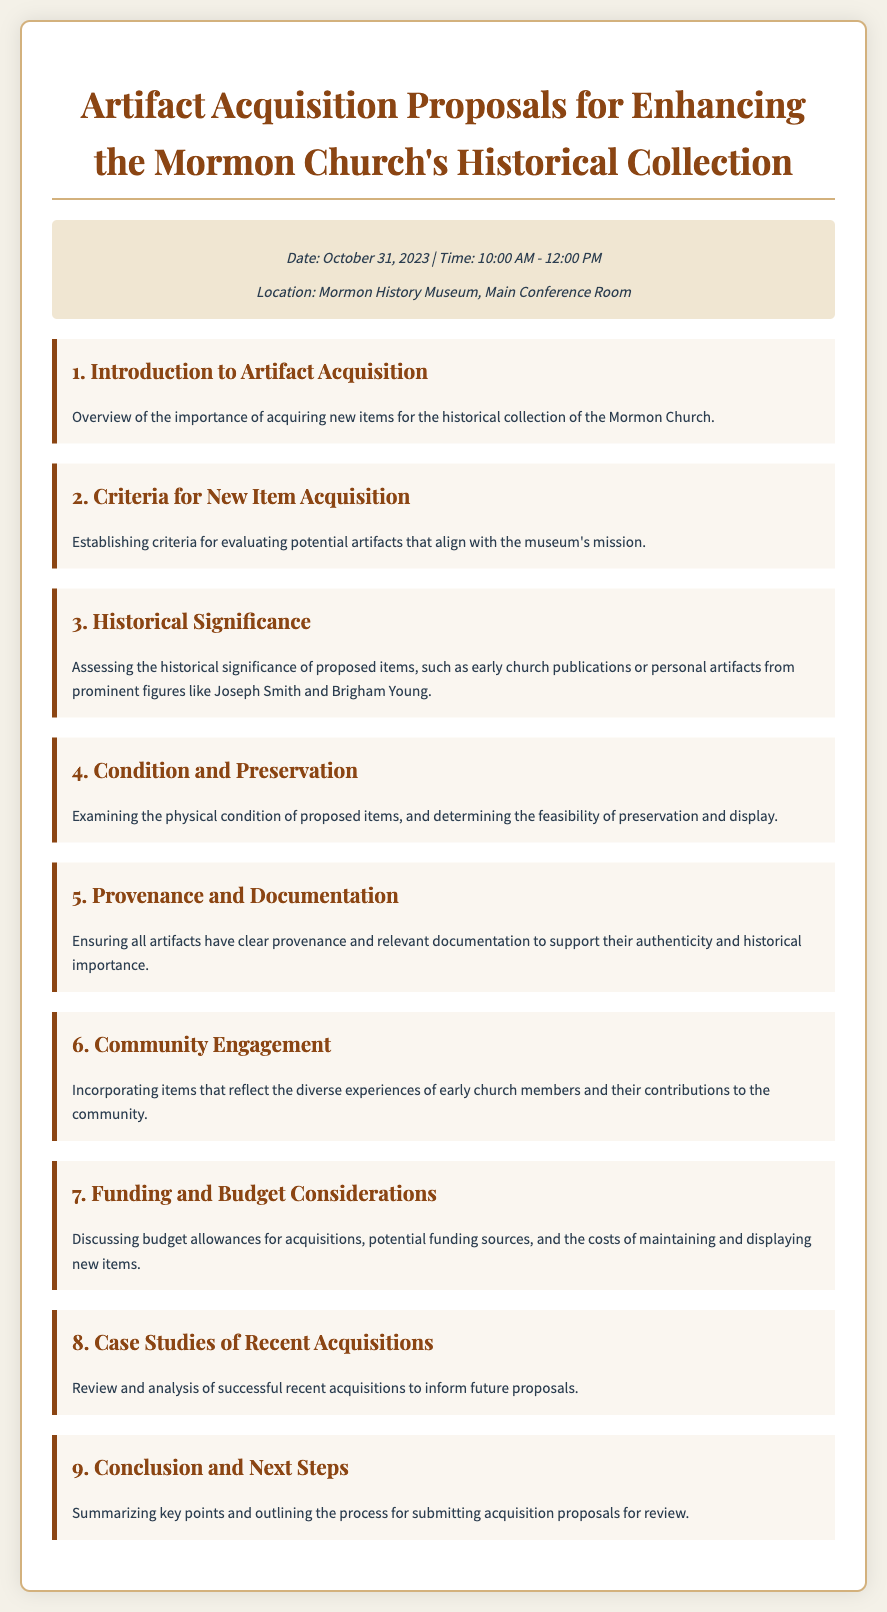What is the date of the meeting? The meeting is scheduled for October 31, 2023, as stated in the meeting info section of the document.
Answer: October 31, 2023 What is the location of the meeting? The meeting location is mentioned in the meeting info section of the document.
Answer: Mormon History Museum, Main Conference Room What is item number 2 in the agenda? The agenda item numbering is provided, and the second item is related to acquisition criteria.
Answer: Criteria for New Item Acquisition Who are two prominent figures referenced in the agenda? The agenda mentions Joseph Smith and Brigham Young as examples of prominent figures.
Answer: Joseph Smith and Brigham Young What is one aspect to consider under "Condition and Preservation"? The agenda highlights examining the physical condition of proposed items as part of this item.
Answer: Physical condition What is discussed in item number 7? The seventh item focuses on budget considerations for artifact acquisitions.
Answer: Funding and Budget Considerations How many items are listed in the agenda? By counting the agenda items in the document, the total number can be derived.
Answer: Nine What is the main purpose of the "Conclusion and Next Steps" item? The last agenda item summarizes key points and outlines the submission process.
Answer: Summarizing key points What is the focus of item number 6? The sixth item emphasizes incorporating items reflecting diverse community experiences.
Answer: Community Engagement 